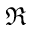Convert formula to latex. <formula><loc_0><loc_0><loc_500><loc_500>\Re</formula> 